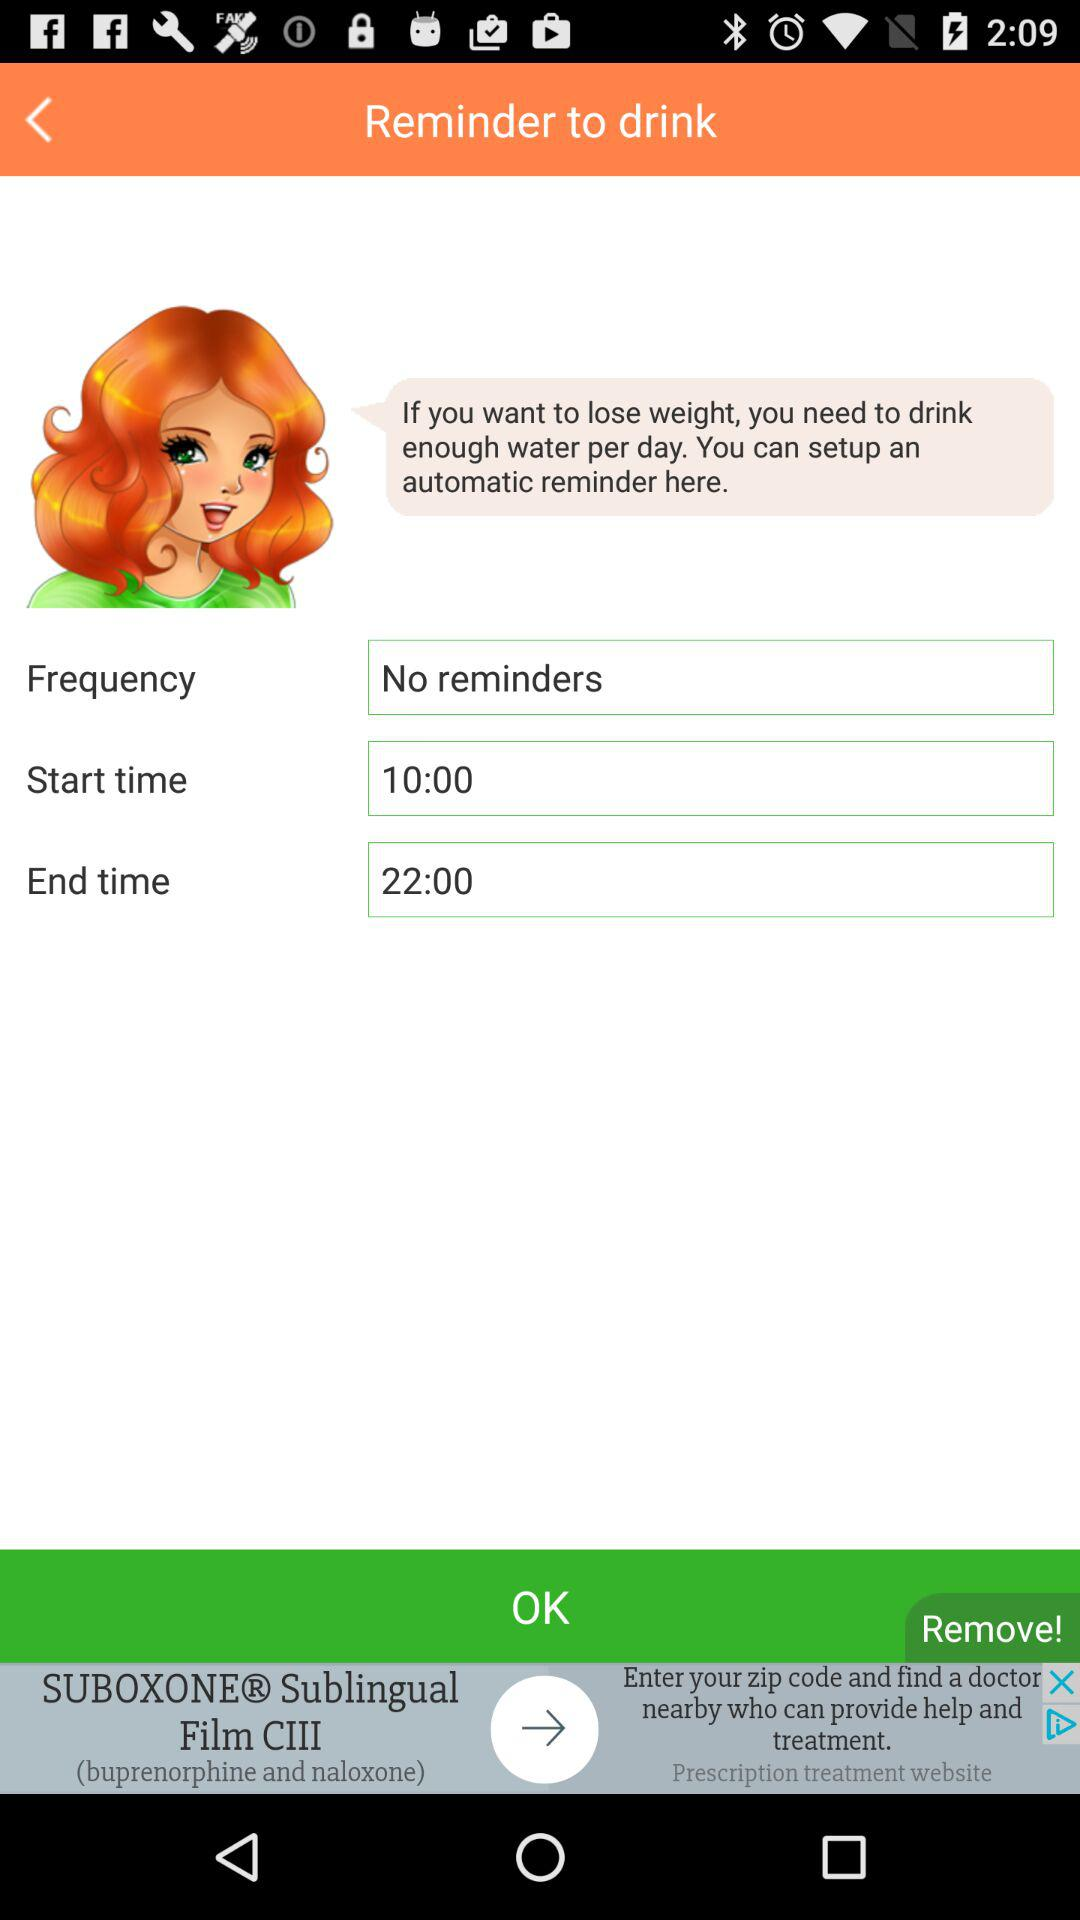Which days of the week are selected?
When the provided information is insufficient, respond with <no answer>. <no answer> 